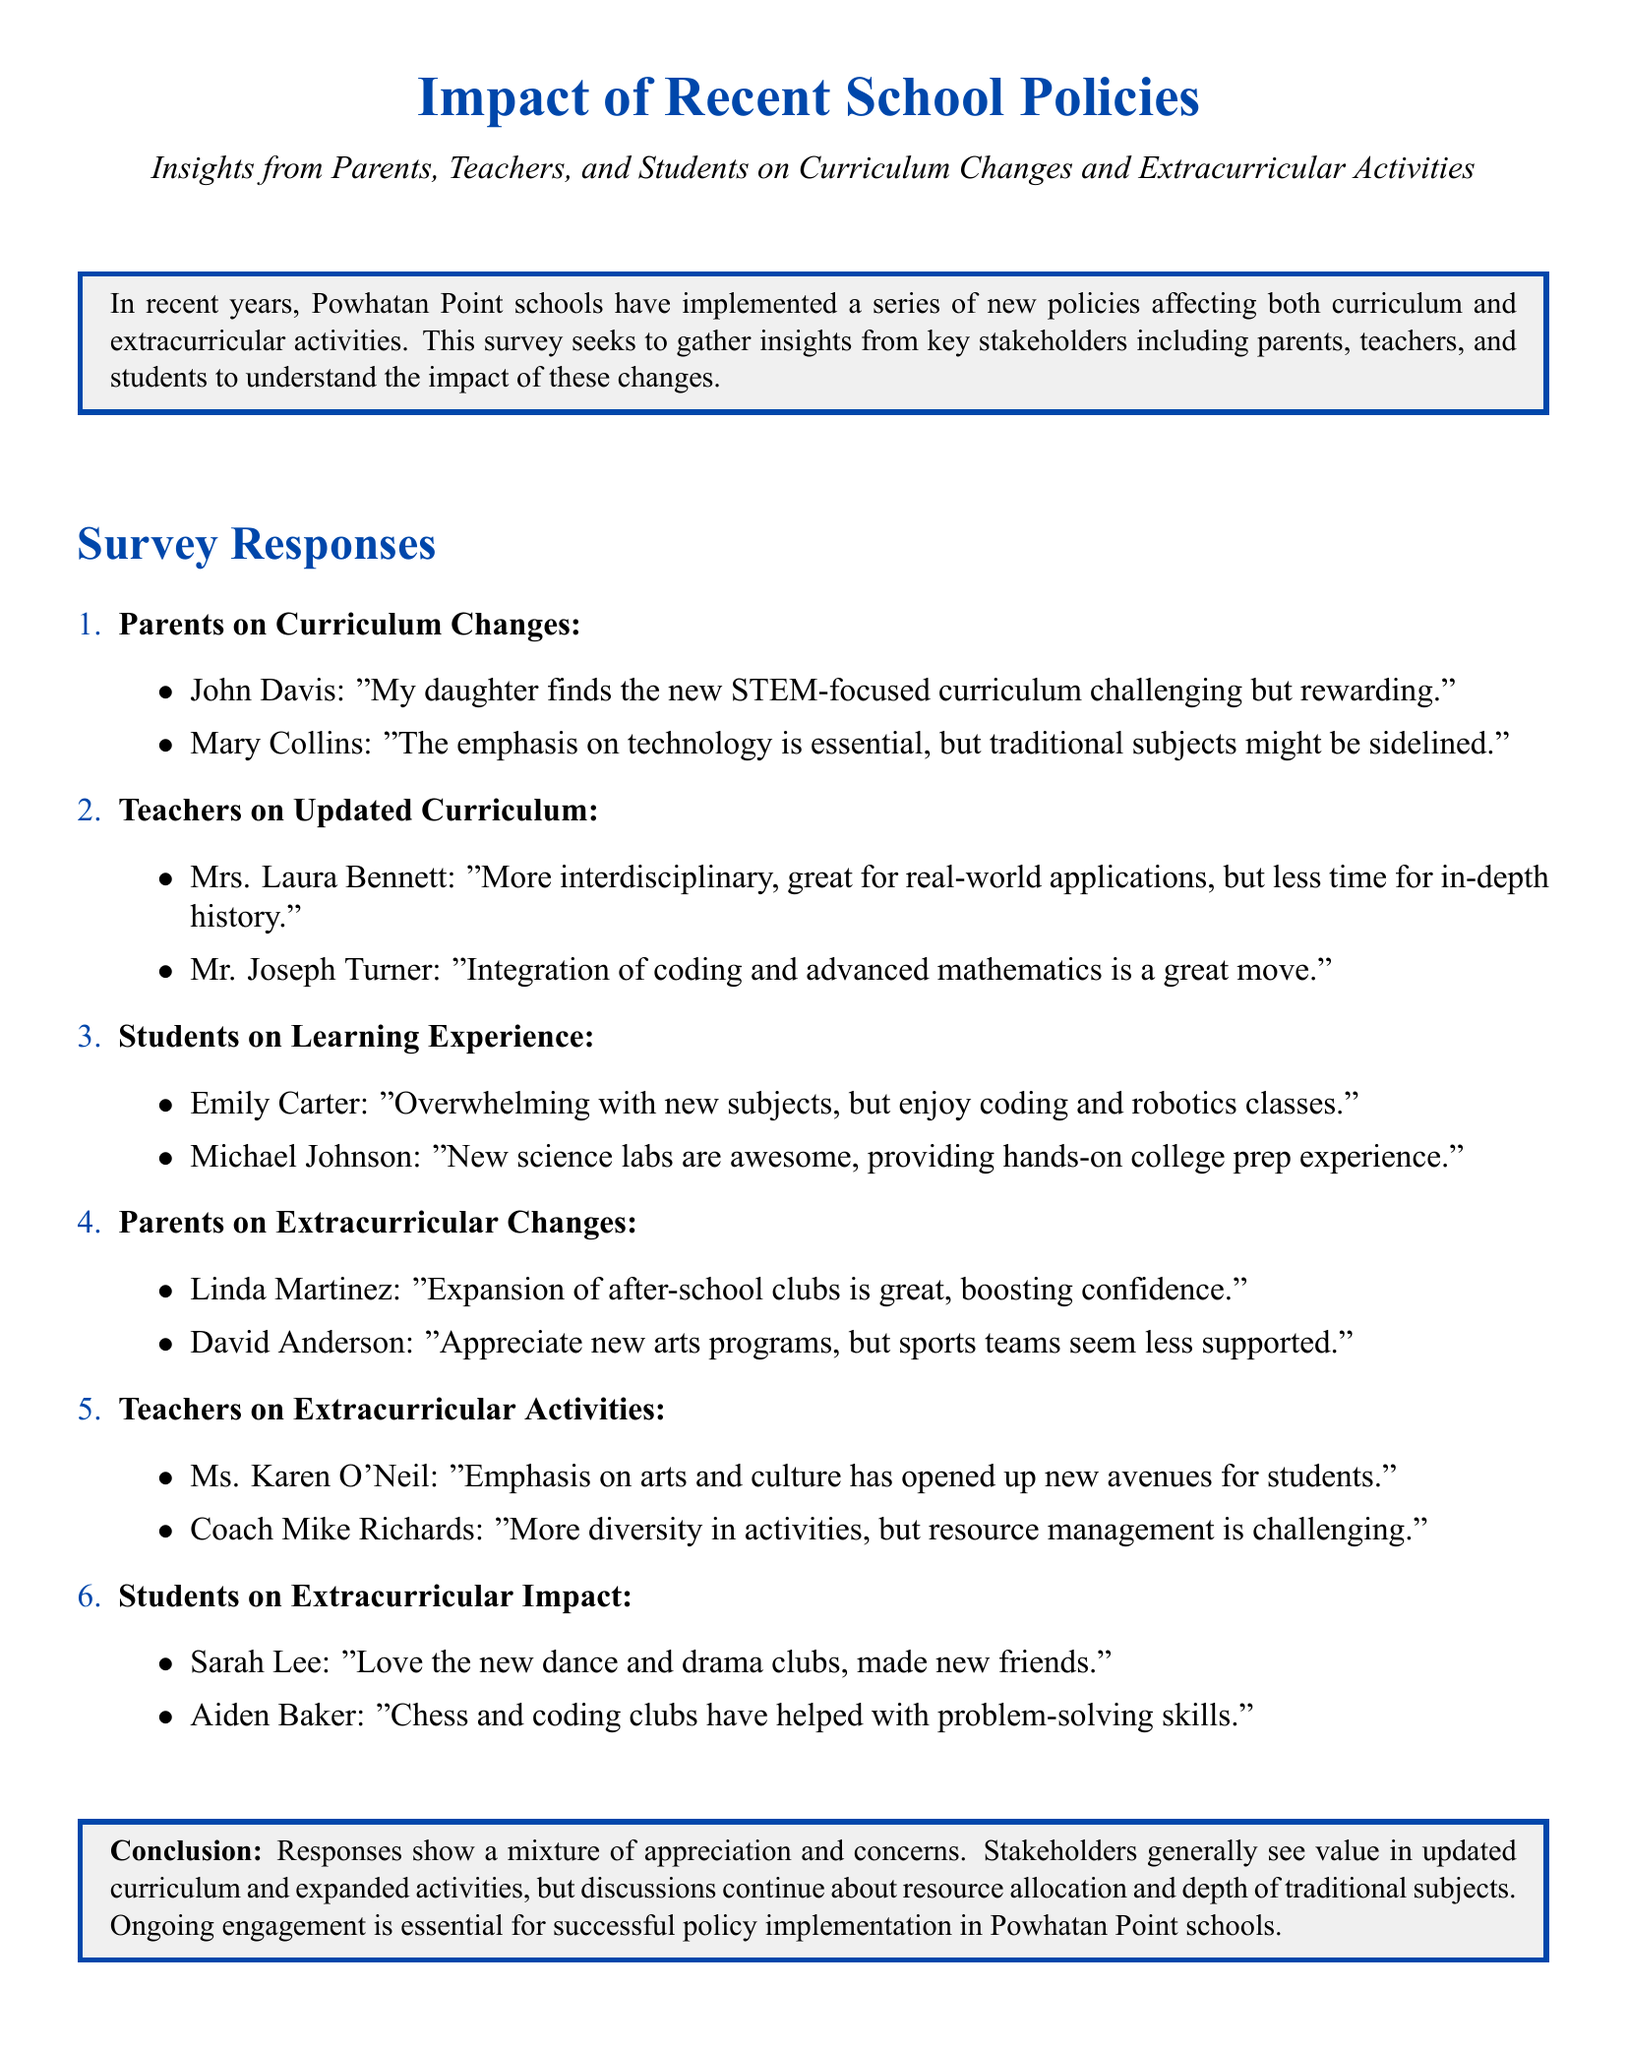what is the name of a parent who commented on curriculum changes? The document lists several parents who commented, one of whom is John Davis.
Answer: John Davis how do parents view the emphasis on technology? Mary Collins expresses that while technology is essential, there are concerns that traditional subjects might be sidelined.
Answer: Essential who believes that the integration of coding and advanced mathematics is a positive change? Mr. Joseph Turner stated that this integration is a great move, which indicates his positive view.
Answer: Mr. Joseph Turner what subject do students find overwhelming according to Emily Carter? Emily Carter specifically mentions that the new subjects she is learning are overwhelming.
Answer: New subjects which extracurricular clubs did Sarah Lee express love for? Sarah Lee mentioned that she loves the new dance and drama clubs.
Answer: Dance and drama clubs what type of programs do parents appreciate according to David Anderson? David Anderson appreciates the new arts programs, indicating positive feedback about these.
Answer: New arts programs who mentioned that the expansion of after-school clubs boosts confidence? This point was made by Linda Martinez, who commented on the impact of after-school clubs.
Answer: Linda Martinez what aspect of extracurricular activities poses a challenge according to Coach Mike Richards? Coach Mike Richards indicated that resource management is challenging when it comes to extracurricular activities.
Answer: Resource management how do teachers generally feel about the updated curriculum? Teachers express a positive sentiment towards the updated curriculum, seeing it as great for real-world applications.
Answer: Positive 